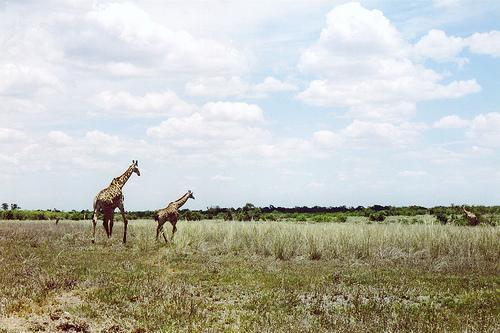How many girraffes are there?
Give a very brief answer. 2. 